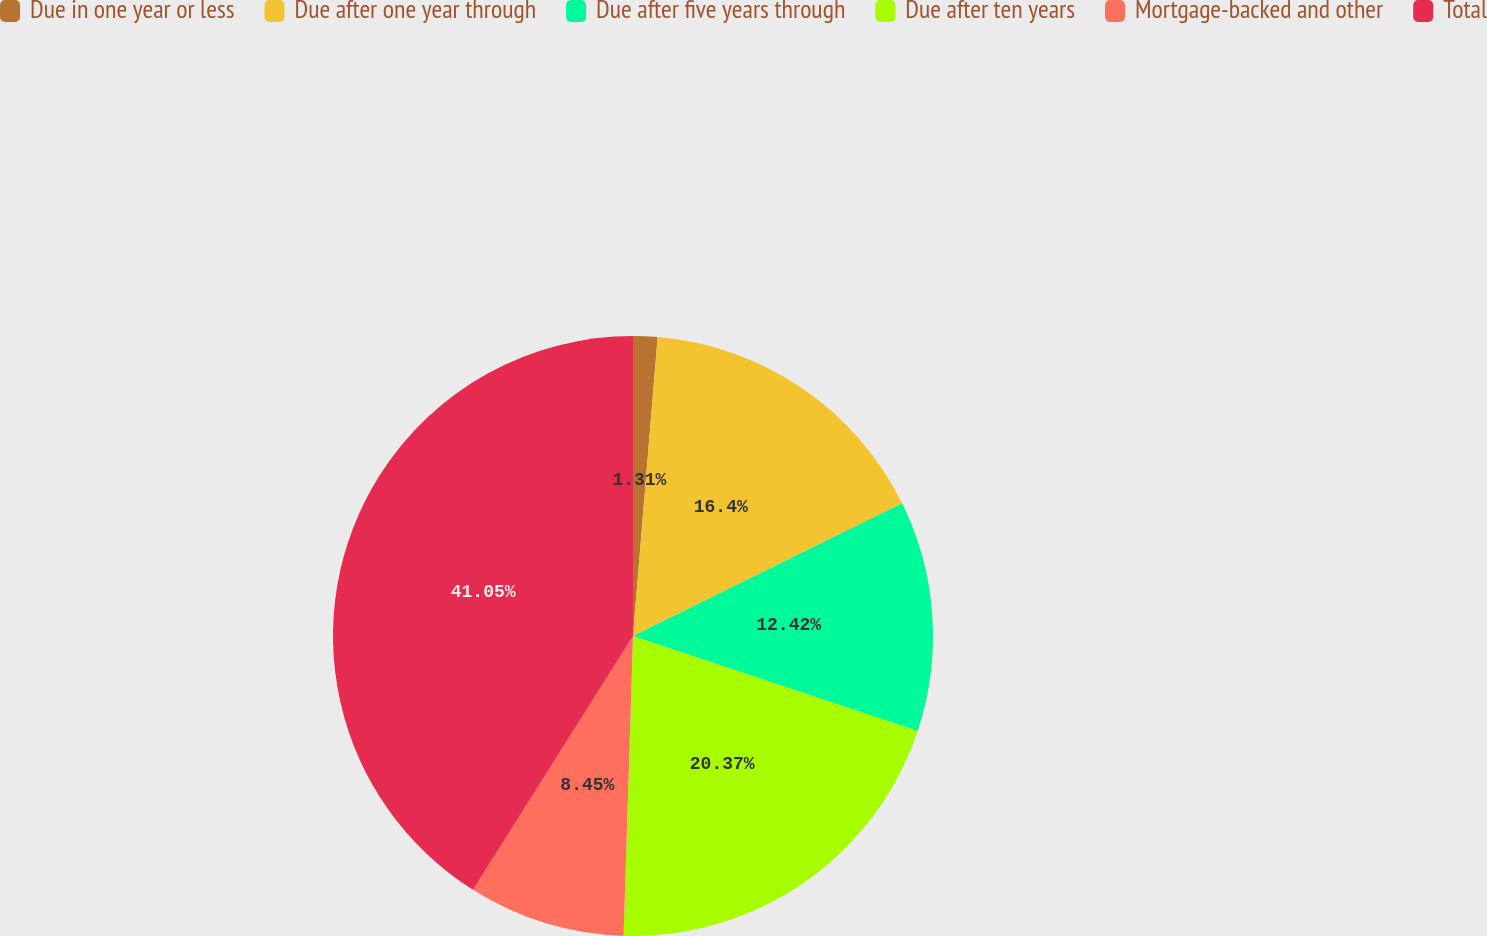<chart> <loc_0><loc_0><loc_500><loc_500><pie_chart><fcel>Due in one year or less<fcel>Due after one year through<fcel>Due after five years through<fcel>Due after ten years<fcel>Mortgage-backed and other<fcel>Total<nl><fcel>1.31%<fcel>16.4%<fcel>12.42%<fcel>20.37%<fcel>8.45%<fcel>41.05%<nl></chart> 